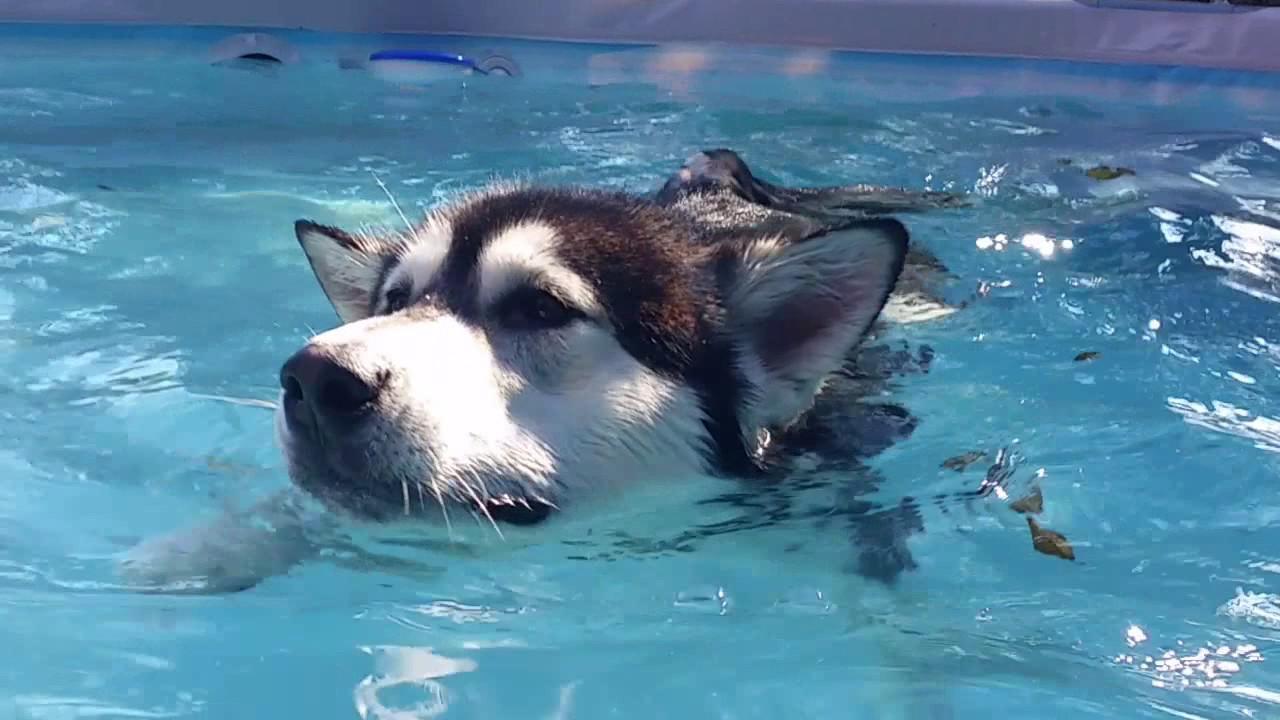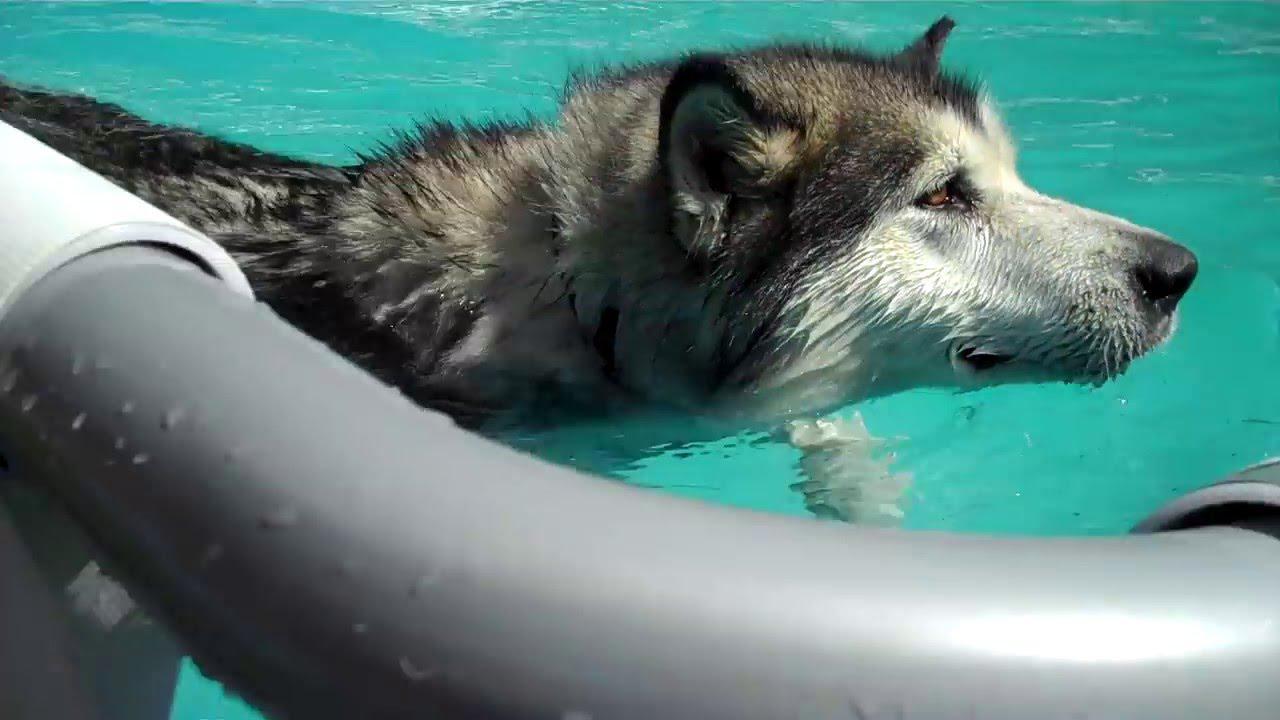The first image is the image on the left, the second image is the image on the right. Examine the images to the left and right. Is the description "In at least one image there is a husky swimming in a pool with a man only wearing shorts." accurate? Answer yes or no. No. The first image is the image on the left, the second image is the image on the right. Assess this claim about the two images: "In one image, a dog is alone in shallow pool water, but in the second image, a dog is with a man in deeper water.". Correct or not? Answer yes or no. No. 